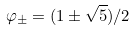Convert formula to latex. <formula><loc_0><loc_0><loc_500><loc_500>\varphi _ { \pm } = ( 1 \pm { \sqrt { 5 } } ) / 2</formula> 